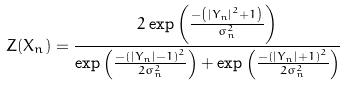Convert formula to latex. <formula><loc_0><loc_0><loc_500><loc_500>Z ( X _ { n } ) = \frac { 2 \exp \left ( \frac { - \left ( | Y _ { n } | ^ { 2 } + 1 \right ) } { \sigma _ { n } ^ { 2 } } \right ) } { \exp \left ( \frac { - \left ( | Y _ { n } | - 1 \right ) ^ { 2 } } { 2 \sigma _ { n } ^ { 2 } } \right ) + \exp \left ( \frac { - \left ( | Y _ { n } | + 1 \right ) ^ { 2 } } { 2 \sigma _ { n } ^ { 2 } } \right ) }</formula> 